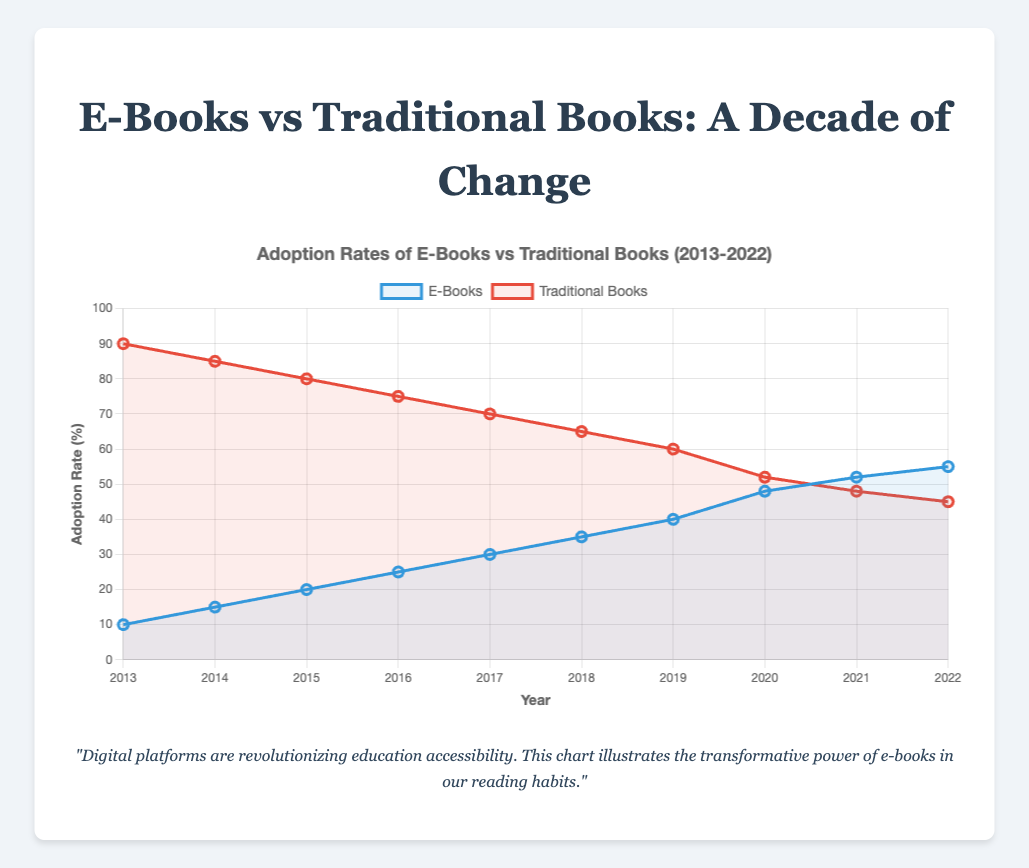How did the adoption rate of e-books and traditional books change between 2013 and 2022? The adoption rate of e-books increased from 10% to 55%, while the adoption rate of traditional books decreased from 90% to 45%. This can be identified by looking at the points for the years 2013 and 2022 for both datasets.
Answer: E-books increased by 45%; Traditional books decreased by 45% What is the difference in adoption rates between e-books and traditional books in 2020? In 2020, the adoption rate for e-books was 48% and for traditional books was 52%. The difference is calculated as 52% - 48% = 4%.
Answer: 4% In which year did e-books adoption surpass traditional books adoption? The adoption rate of e-books surpassed traditional books in 2021. This can be seen where the line representing e-books crosses above the line representing traditional books.
Answer: 2021 By how much did the adoption rates of e-books increase from 2015 to 2020? The adoption rate for e-books in 2015 was 20% and in 2020 it was 48%. The increase is calculated as 48% - 20% = 28%.
Answer: 28% Which year had the smallest gap between the adoption rates of e-books and traditional books? The smallest gap can be observed in 2021 when the rates were 52% for e-books and 48% for traditional books, resulting in a 4% difference.
Answer: 2021 Which line on the chart represents e-books, and which represents traditional books? The line representing e-books is blue, and the line representing traditional books is red. This can be identified by the colors and labels in the legend.
Answer: E-books: blue, Traditional books: red What is the average adoption rate of traditional books over the decade? To find the average adoption rate of traditional books, sum the yearly percentages and divide by the number of years: (90 + 85 + 80 + 75 + 70 + 65 + 60 + 52 + 48 + 45) / 10 = 67%.
Answer: 67% Which year saw the largest increase in e-books adoption rate compared to the previous year? The largest year-over-year increase in e-books adoption rate was from 2019 (40%) to 2020 (48%), an increase of 8%.
Answer: 2020 What is the total combined adoption rate for both e-books and traditional books in the year 2017? The combined adoption rate in 2017 is the sum of the rates for e-books (30%) and traditional books (70%), which is 100%.
Answer: 100% How does the trend in adoption rates of e-books compare visually to traditional books over the ten years? Visually, the trend lines show a steady increase in e-books adoption and a steady decline in traditional books adoption. The blue line (e-books) slopes upward while the red line (traditional books) slopes downward over the ten years.
Answer: E-books: upward trend; Traditional books: downward trend 